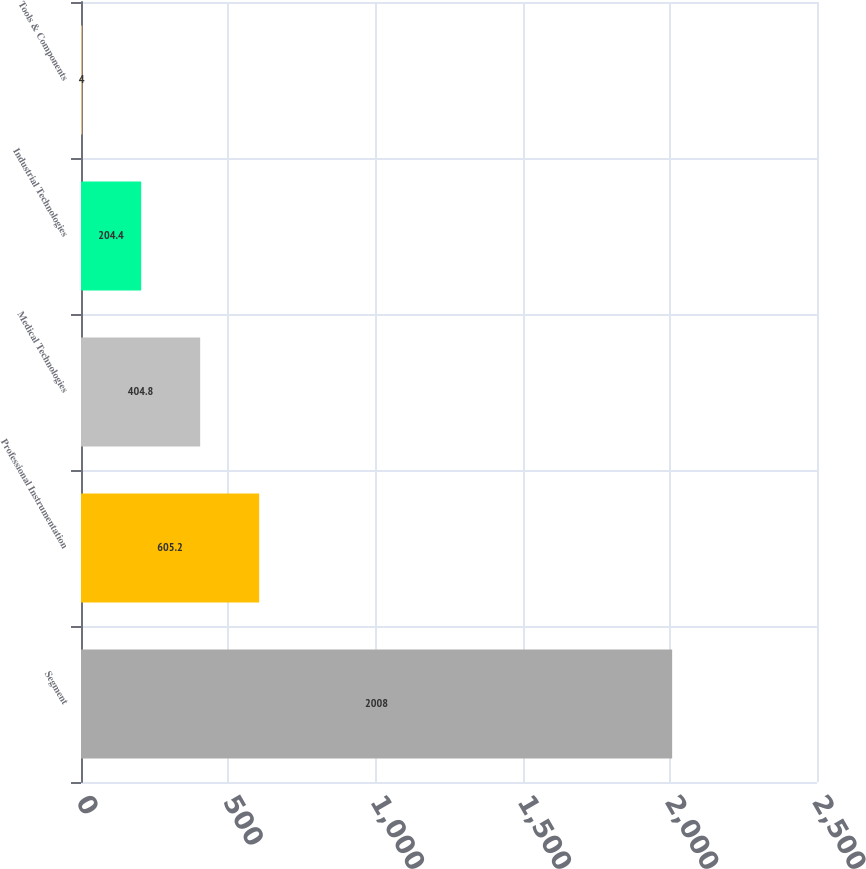<chart> <loc_0><loc_0><loc_500><loc_500><bar_chart><fcel>Segment<fcel>Professional Instrumentation<fcel>Medical Technologies<fcel>Industrial Technologies<fcel>Tools & Components<nl><fcel>2008<fcel>605.2<fcel>404.8<fcel>204.4<fcel>4<nl></chart> 